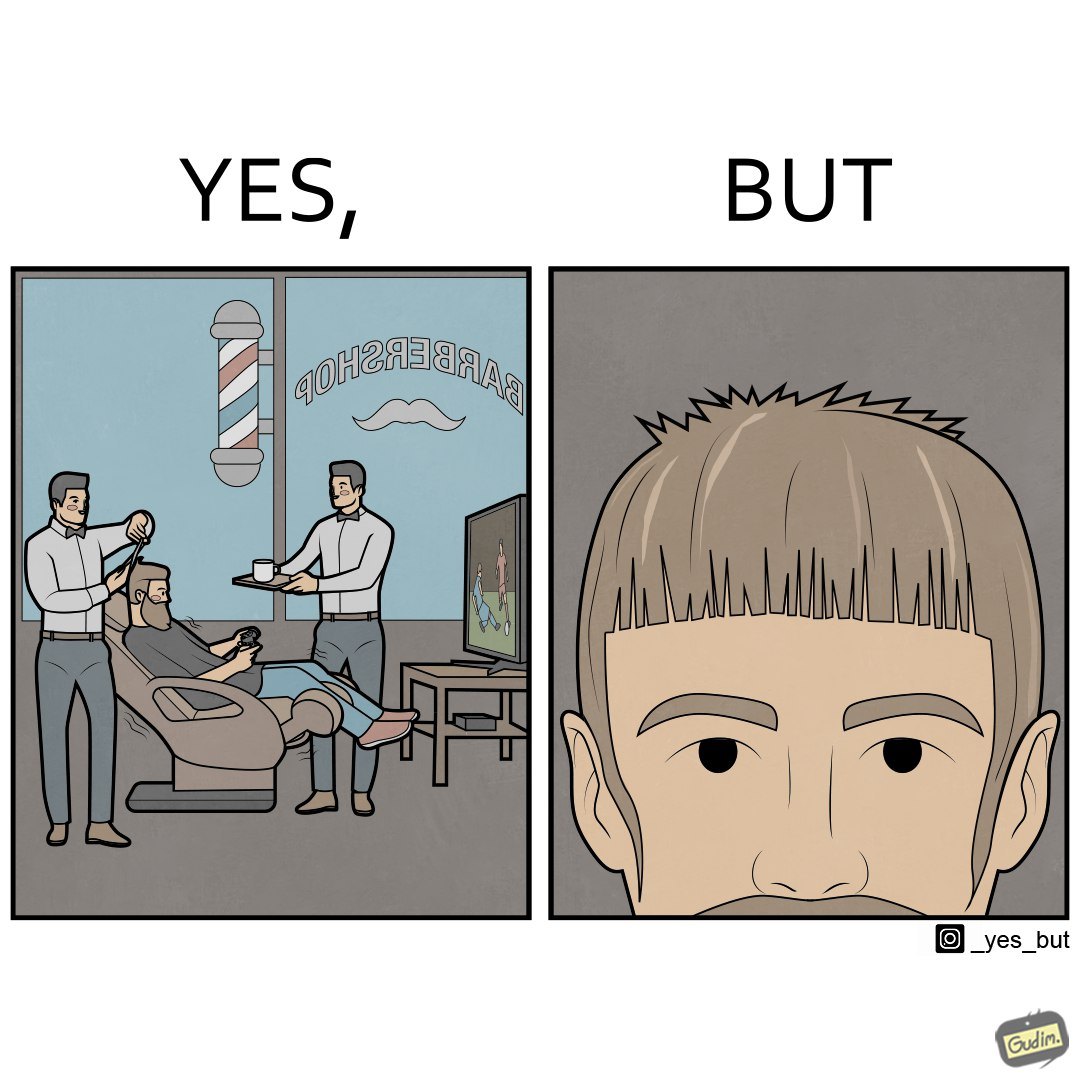Would you classify this image as satirical? Yes, this image is satirical. 